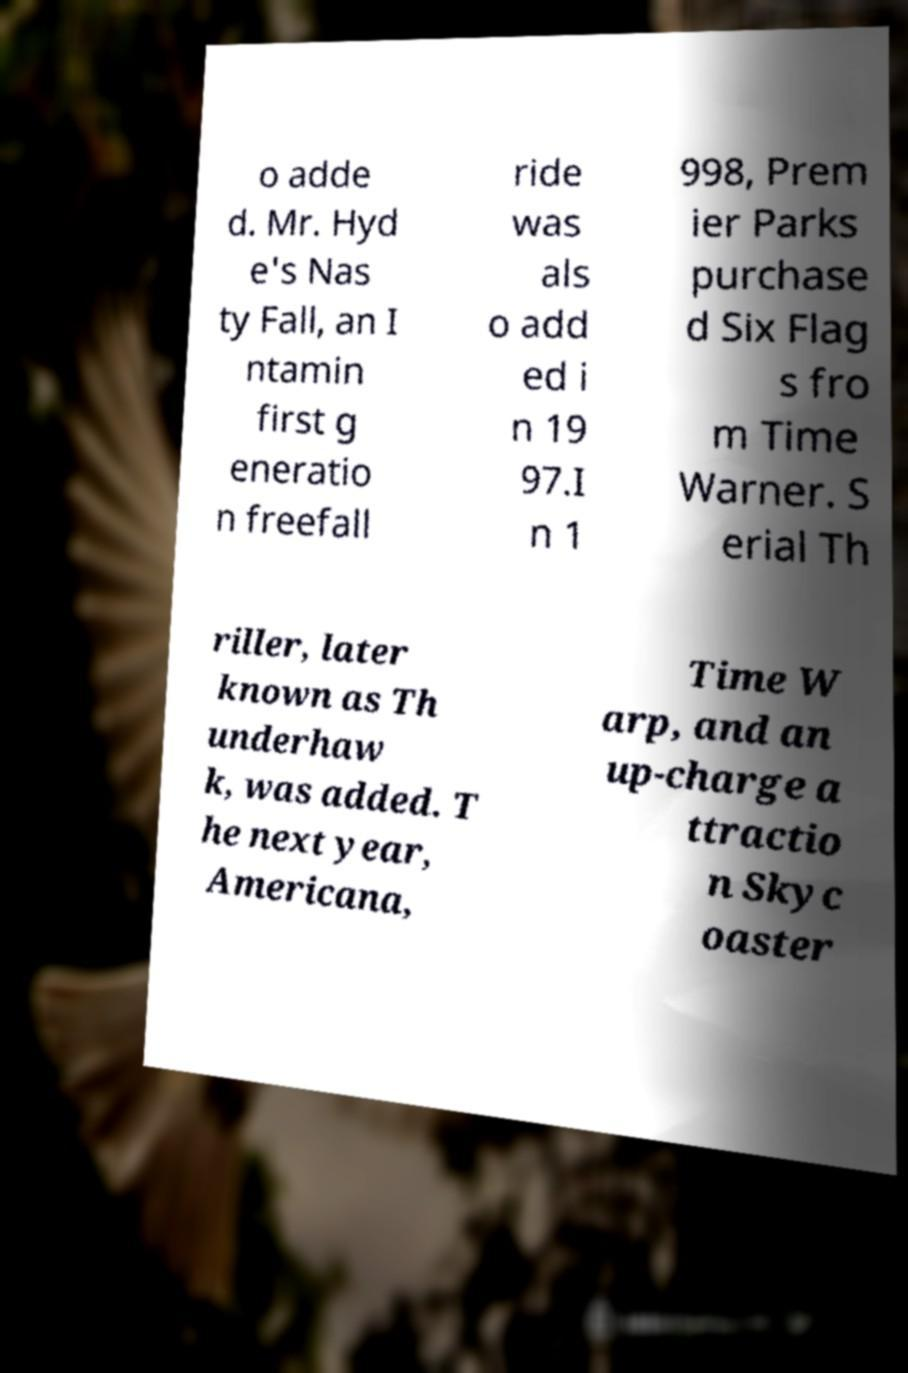Please identify and transcribe the text found in this image. o adde d. Mr. Hyd e's Nas ty Fall, an I ntamin first g eneratio n freefall ride was als o add ed i n 19 97.I n 1 998, Prem ier Parks purchase d Six Flag s fro m Time Warner. S erial Th riller, later known as Th underhaw k, was added. T he next year, Americana, Time W arp, and an up-charge a ttractio n Skyc oaster 